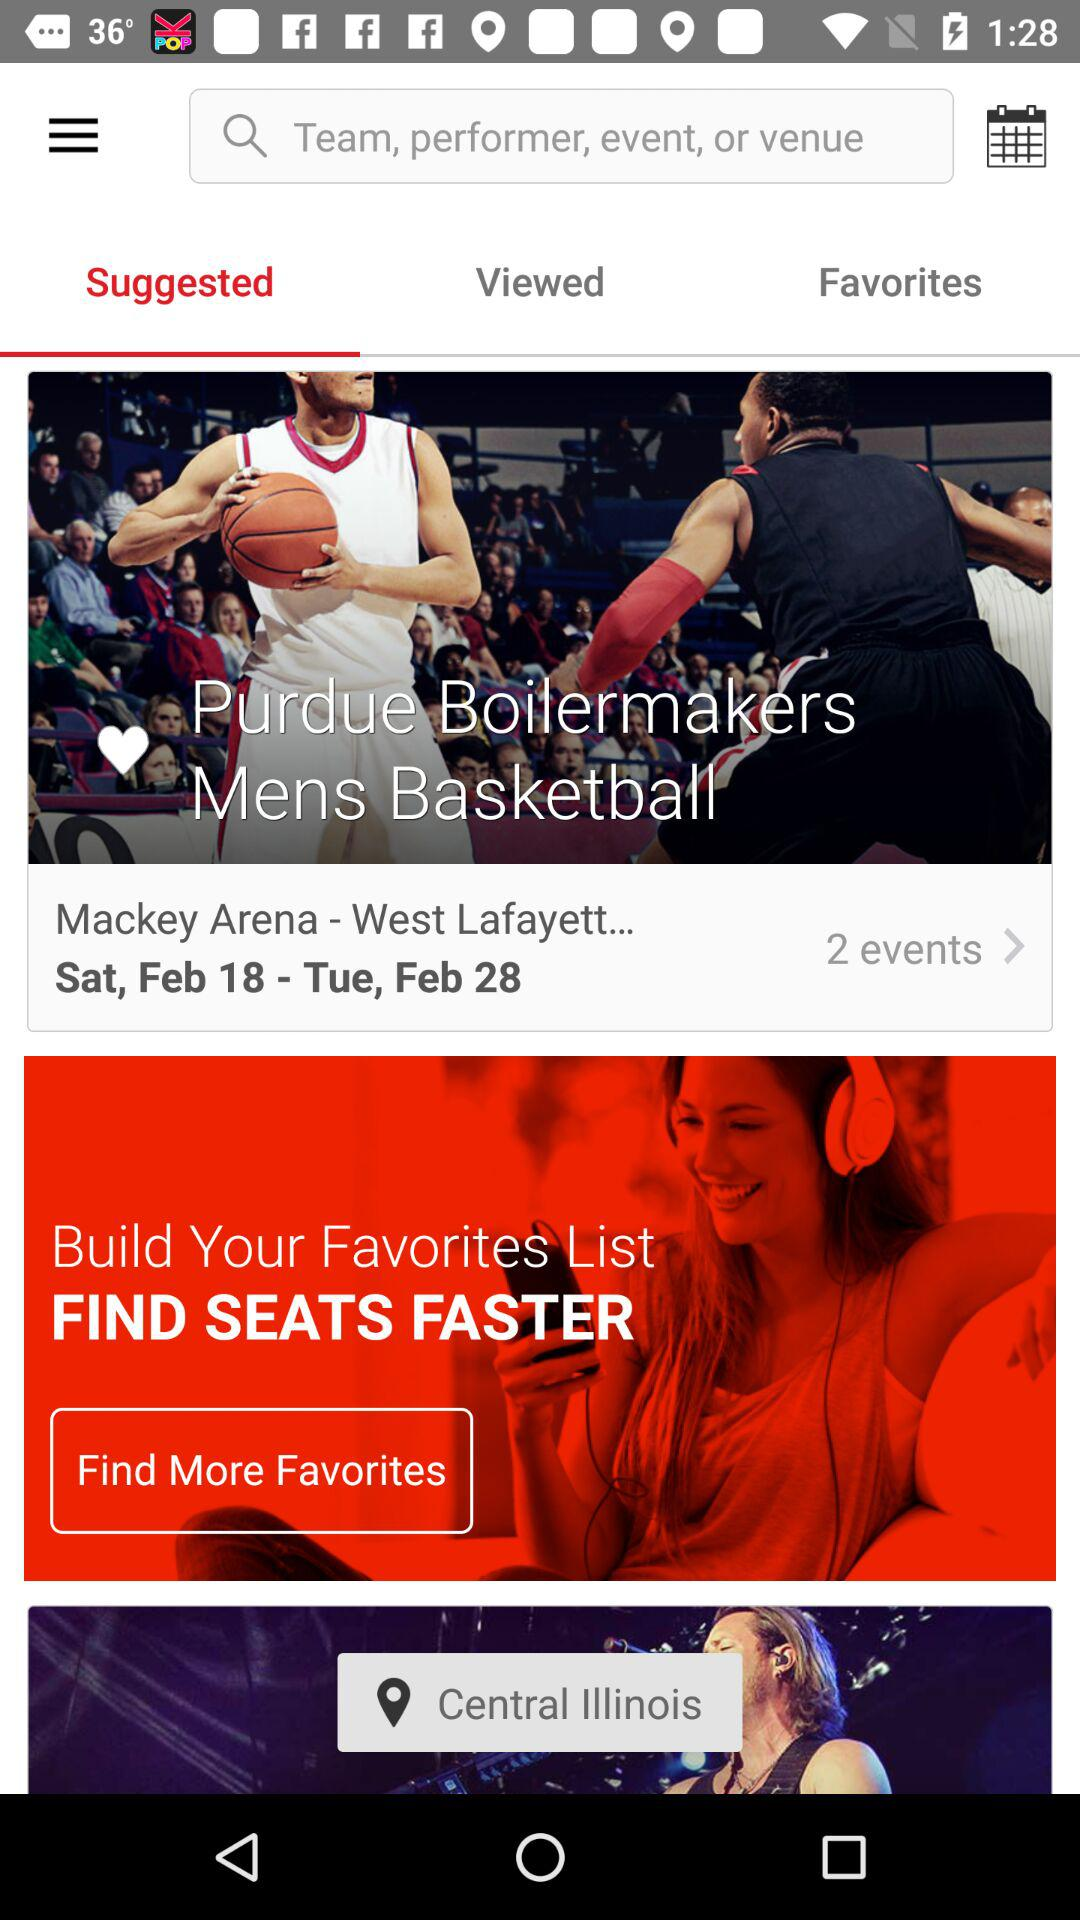How many events are there? There are 2 events. 